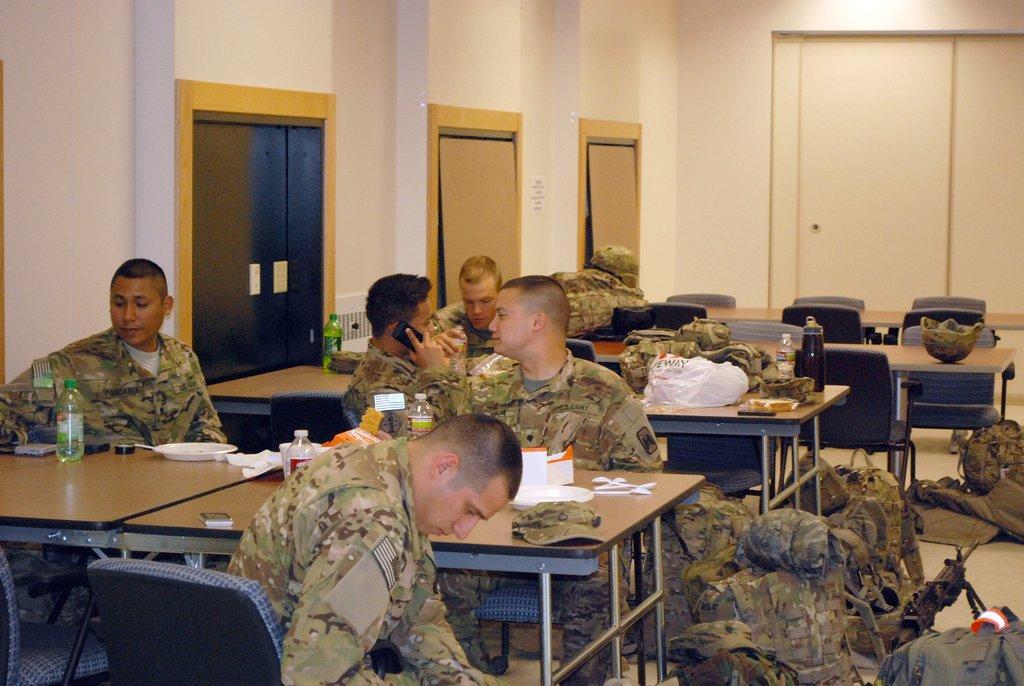Please provide a concise description of this image. The image is taken in the room. The room is filled with tables and chairs. We can see many cops in the room who are sitting on the chairs. There are bottles, plates, caps, covers, some food placed on the table. In the background there are doors and a wall. 